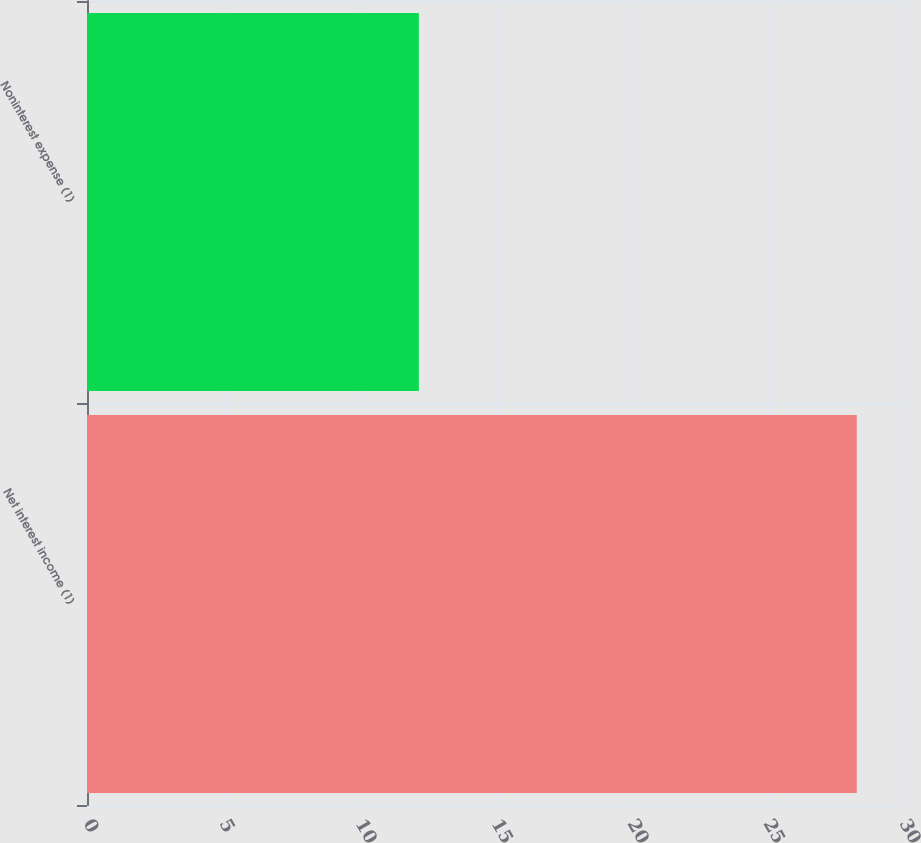<chart> <loc_0><loc_0><loc_500><loc_500><bar_chart><fcel>Net interest income (1)<fcel>Noninterest expense (1)<nl><fcel>28.3<fcel>12.2<nl></chart> 